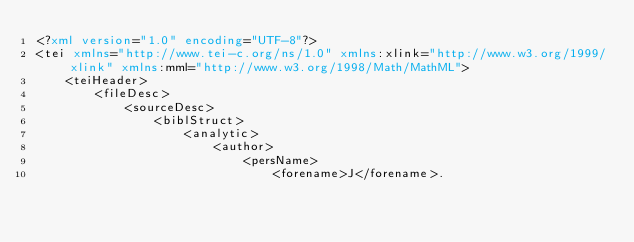<code> <loc_0><loc_0><loc_500><loc_500><_XML_><?xml version="1.0" encoding="UTF-8"?>
<tei xmlns="http://www.tei-c.org/ns/1.0" xmlns:xlink="http://www.w3.org/1999/xlink" xmlns:mml="http://www.w3.org/1998/Math/MathML">
	<teiHeader>
		<fileDesc>
			<sourceDesc>
				<biblStruct>
					<analytic>
						<author>
							<persName>
								<forename>J</forename>.</code> 